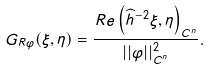Convert formula to latex. <formula><loc_0><loc_0><loc_500><loc_500>G _ { R \varphi } ( \xi , \eta ) = \frac { R e \left ( { \widehat { h } } ^ { - 2 } \xi , \eta \right ) _ { C ^ { n } } } { | | \varphi | | ^ { 2 } _ { C ^ { n } } } .</formula> 